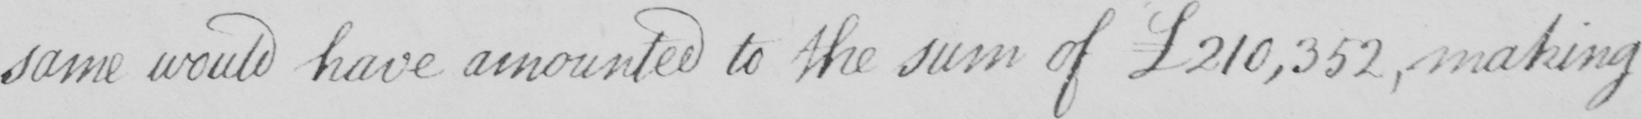What does this handwritten line say? same would have amounted to the sum of £210,352 , making 